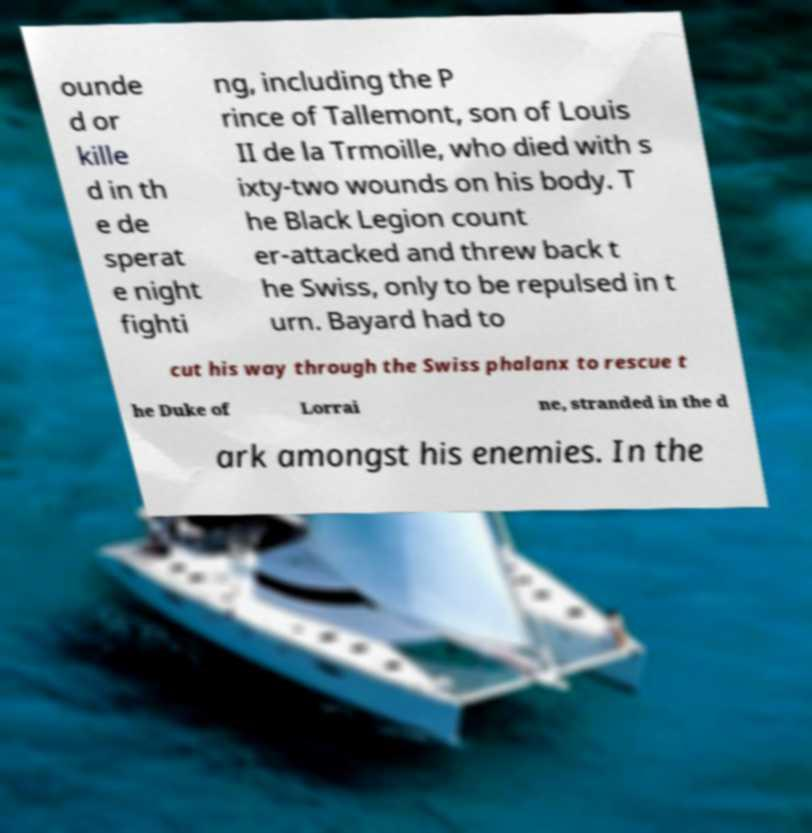There's text embedded in this image that I need extracted. Can you transcribe it verbatim? ounde d or kille d in th e de sperat e night fighti ng, including the P rince of Tallemont, son of Louis II de la Trmoille, who died with s ixty-two wounds on his body. T he Black Legion count er-attacked and threw back t he Swiss, only to be repulsed in t urn. Bayard had to cut his way through the Swiss phalanx to rescue t he Duke of Lorrai ne, stranded in the d ark amongst his enemies. In the 